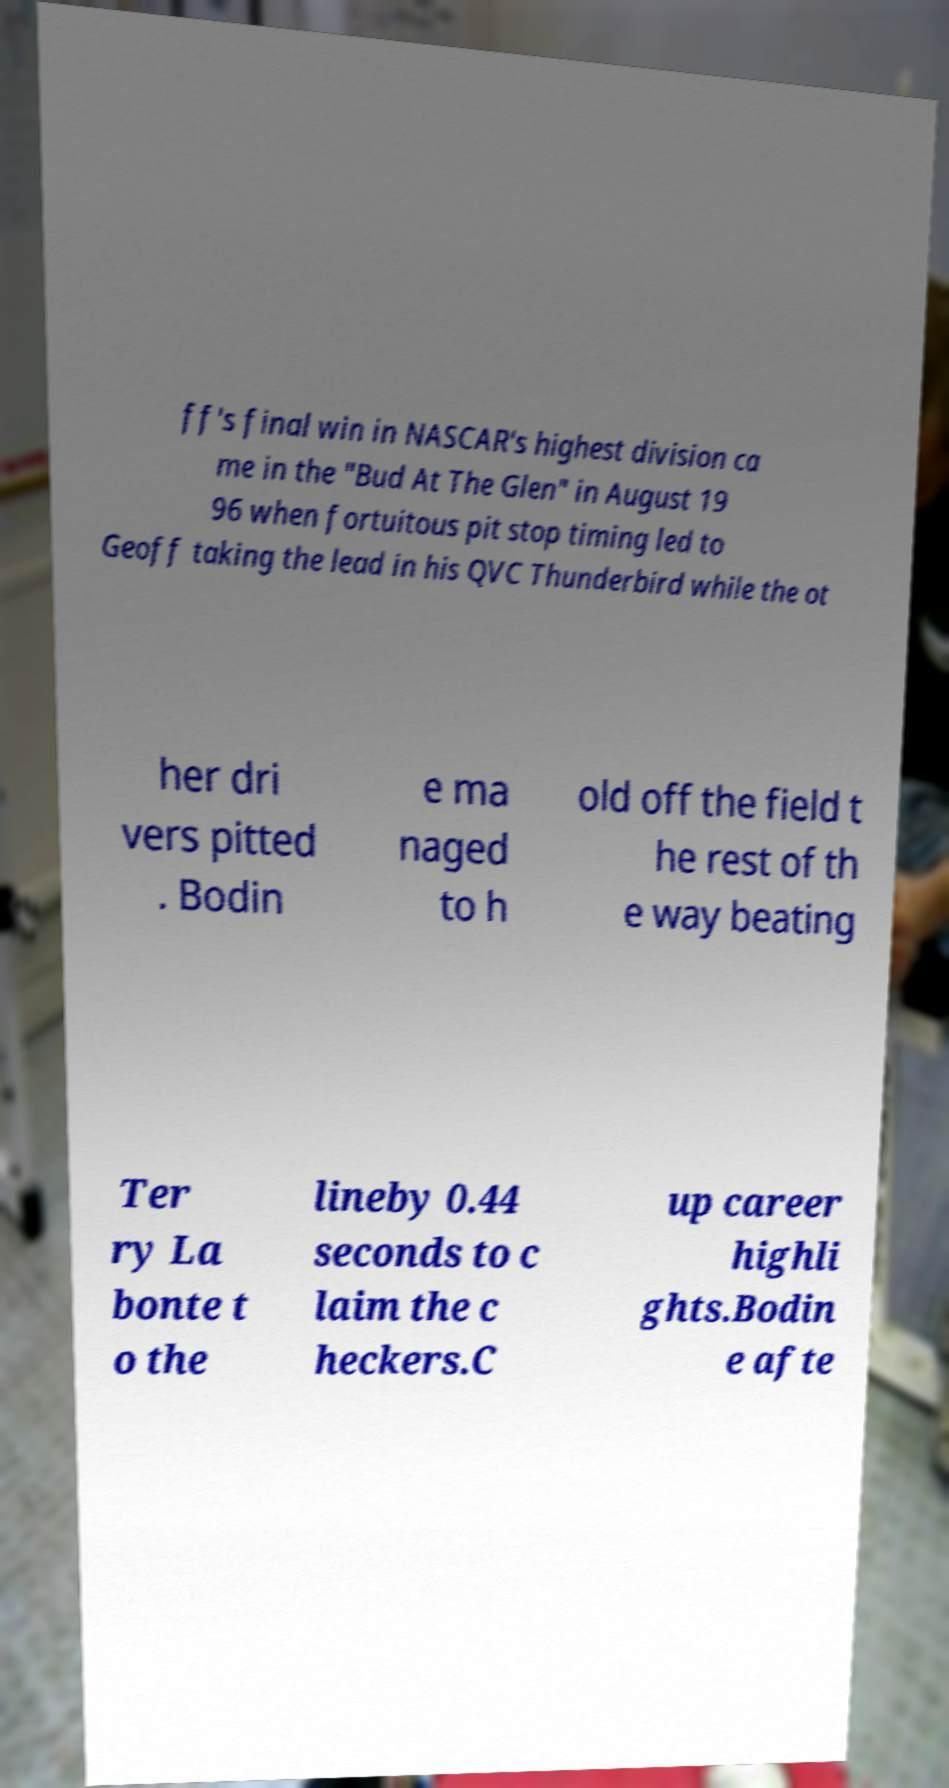Could you extract and type out the text from this image? ff's final win in NASCAR's highest division ca me in the "Bud At The Glen" in August 19 96 when fortuitous pit stop timing led to Geoff taking the lead in his QVC Thunderbird while the ot her dri vers pitted . Bodin e ma naged to h old off the field t he rest of th e way beating Ter ry La bonte t o the lineby 0.44 seconds to c laim the c heckers.C up career highli ghts.Bodin e afte 